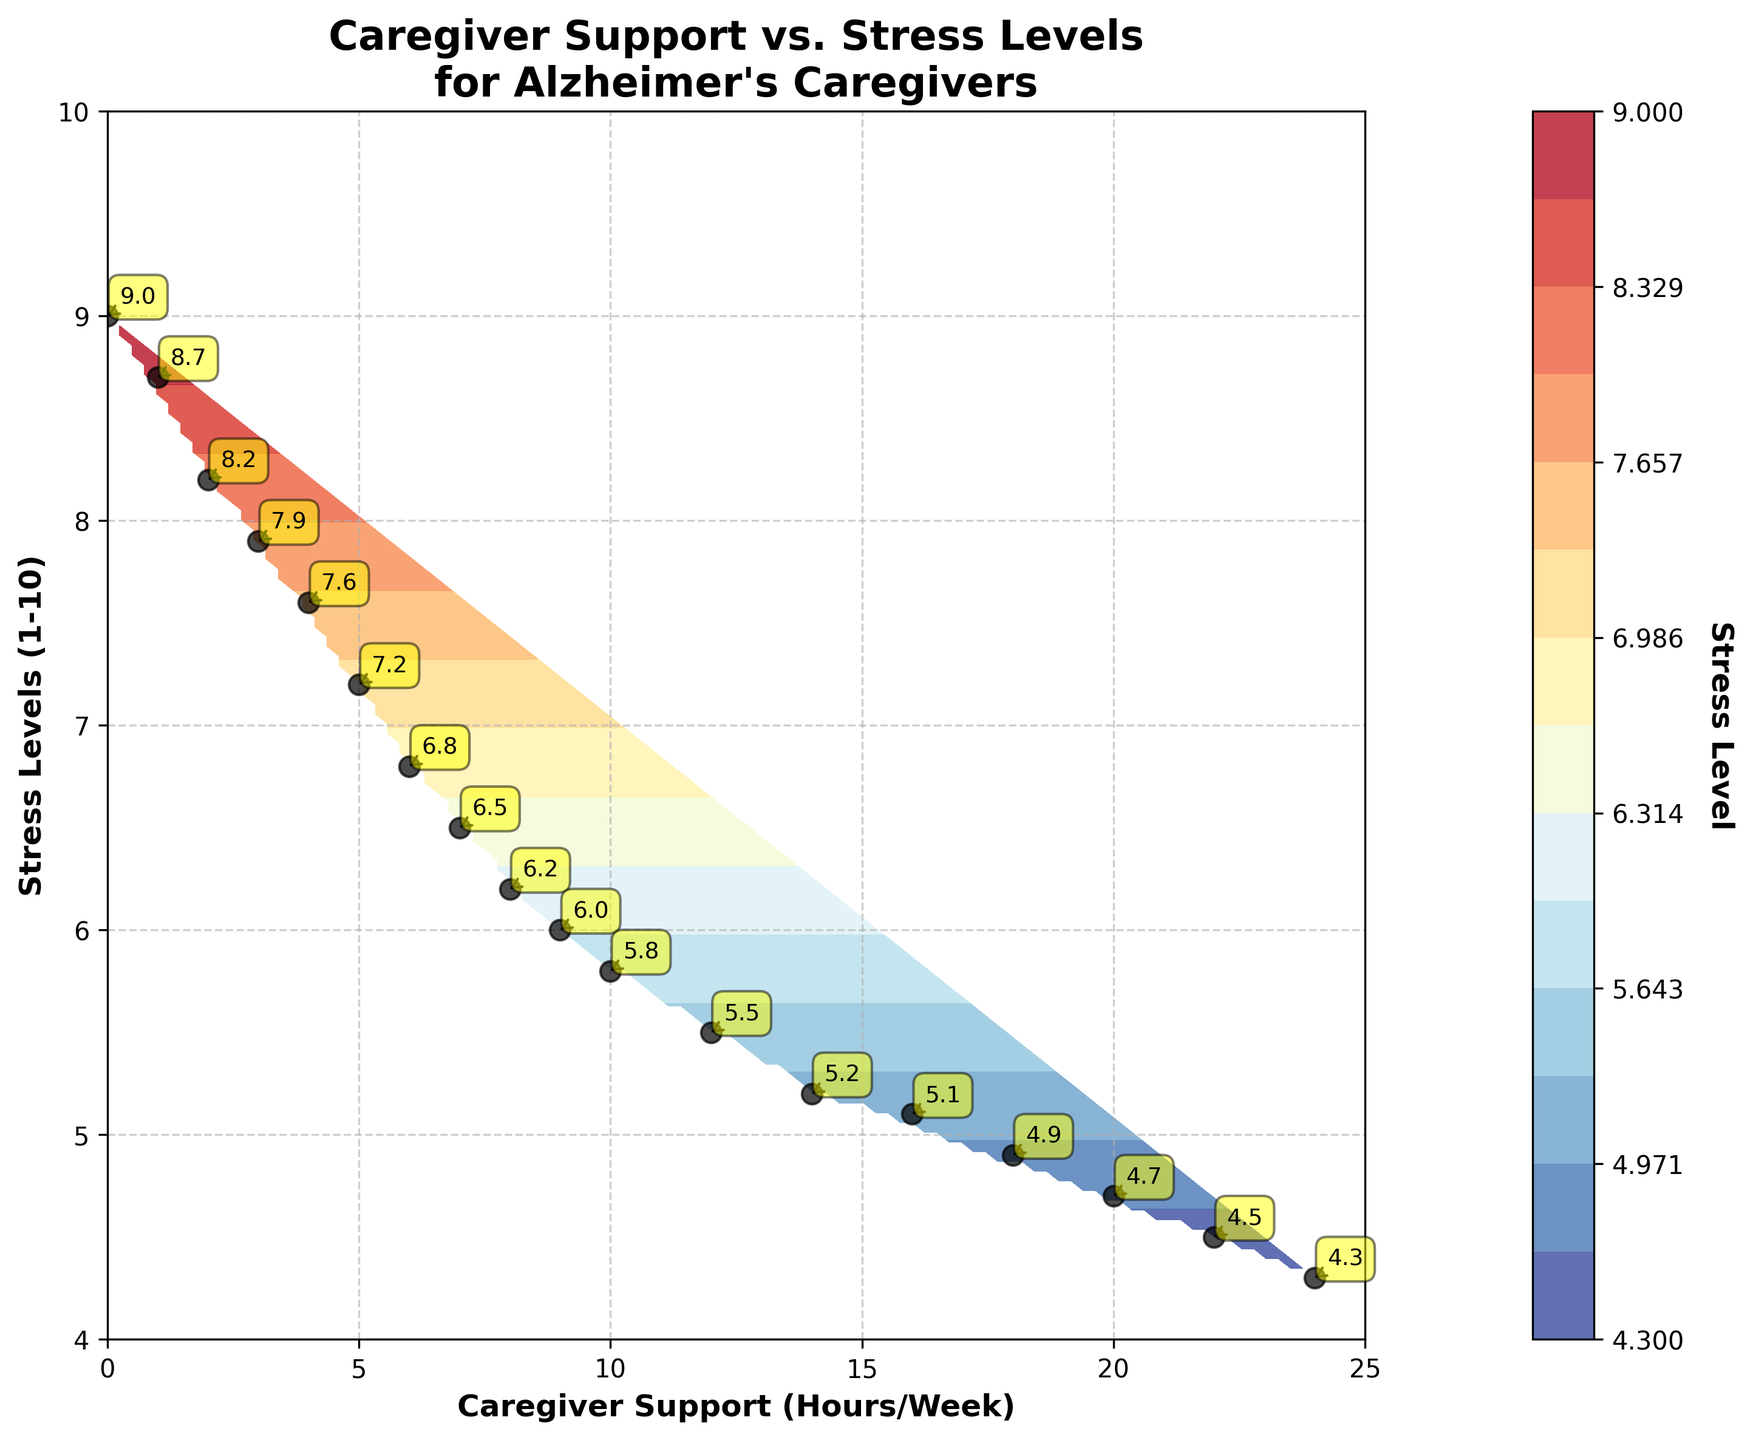What is the title of the plot? The title is usually displayed at the top of the plot, summarizing the data being analyzed. Here, it clearly states the main focus of the plot.
Answer: Caregiver Support vs. Stress Levels for Alzheimer's Caregivers What is the x-axis label on the plot? The x-axis label describes the data represented along the horizontal axis. It helps to understand what the values along the x-axis represent.
Answer: Caregiver Support (Hours/Week) What is the color used for the stress level annotation boxes? The color inside the annotation boxes is usually quite distinct to catch attention. In this plot, they help in displaying the specific stress levels for different caregiver support hours.
Answer: Yellow How many distinct contour levels are used in the plot? Contour levels in the plot represent different ranges of stress levels. They provide a visual representation of how the stress levels vary. By counting the lines in the color bar or contour lines, we get the distinct levels.
Answer: 15 How are the data points represented on the plot? Data points are usually marked to show the exact values used for plotting the graph. In this case, they’re marked for clear visibility.
Answer: Black circles (ko markers) What is the general trend observed between caregiver support (hours/week) and stress levels? Observing from left to right across the plot, the contour colors and the numerical markers will highlight this pattern.
Answer: As caregiver support hours increase, stress levels decrease Which caregiver support value corresponds to the lowest stress level indicated on the plot? By looking at the numeric annotations or the axis intersections, we can find the support value corresponding to the minimum stress level.
Answer: 24 hours/week What is the stress level when caregiver support is at 12 hours per week? The specific value can be found by looking at the annotation near the 12 hours/week mark on the x-axis.
Answer: 5.5 Compare the stress levels at 3 hours/week and 15 hours/week of caregiver support. By observing the stress annotations at these specific support hours, the values can be compared directly.
Answer: 7.9 at 3 hours/week and 5.1 at 15 hours/week How does the stress level change from 0 to 6 hours/week of caregiver support? Look at the numeric stress values annotated along the contour line from 0 to 6 hours on the x-axis. Calculate the difference to find the change.
Answer: The stress level decreases from 9 to 6.8, a change of 2.2 